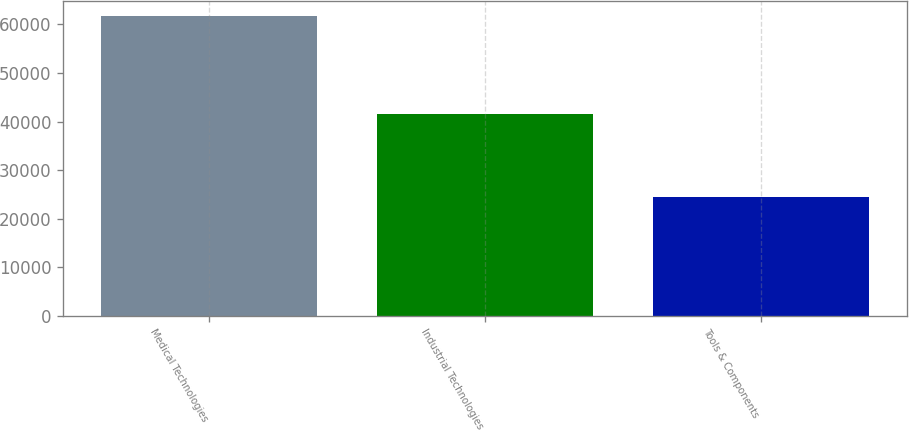Convert chart. <chart><loc_0><loc_0><loc_500><loc_500><bar_chart><fcel>Medical Technologies<fcel>Industrial Technologies<fcel>Tools & Components<nl><fcel>61725<fcel>41548<fcel>24375<nl></chart> 